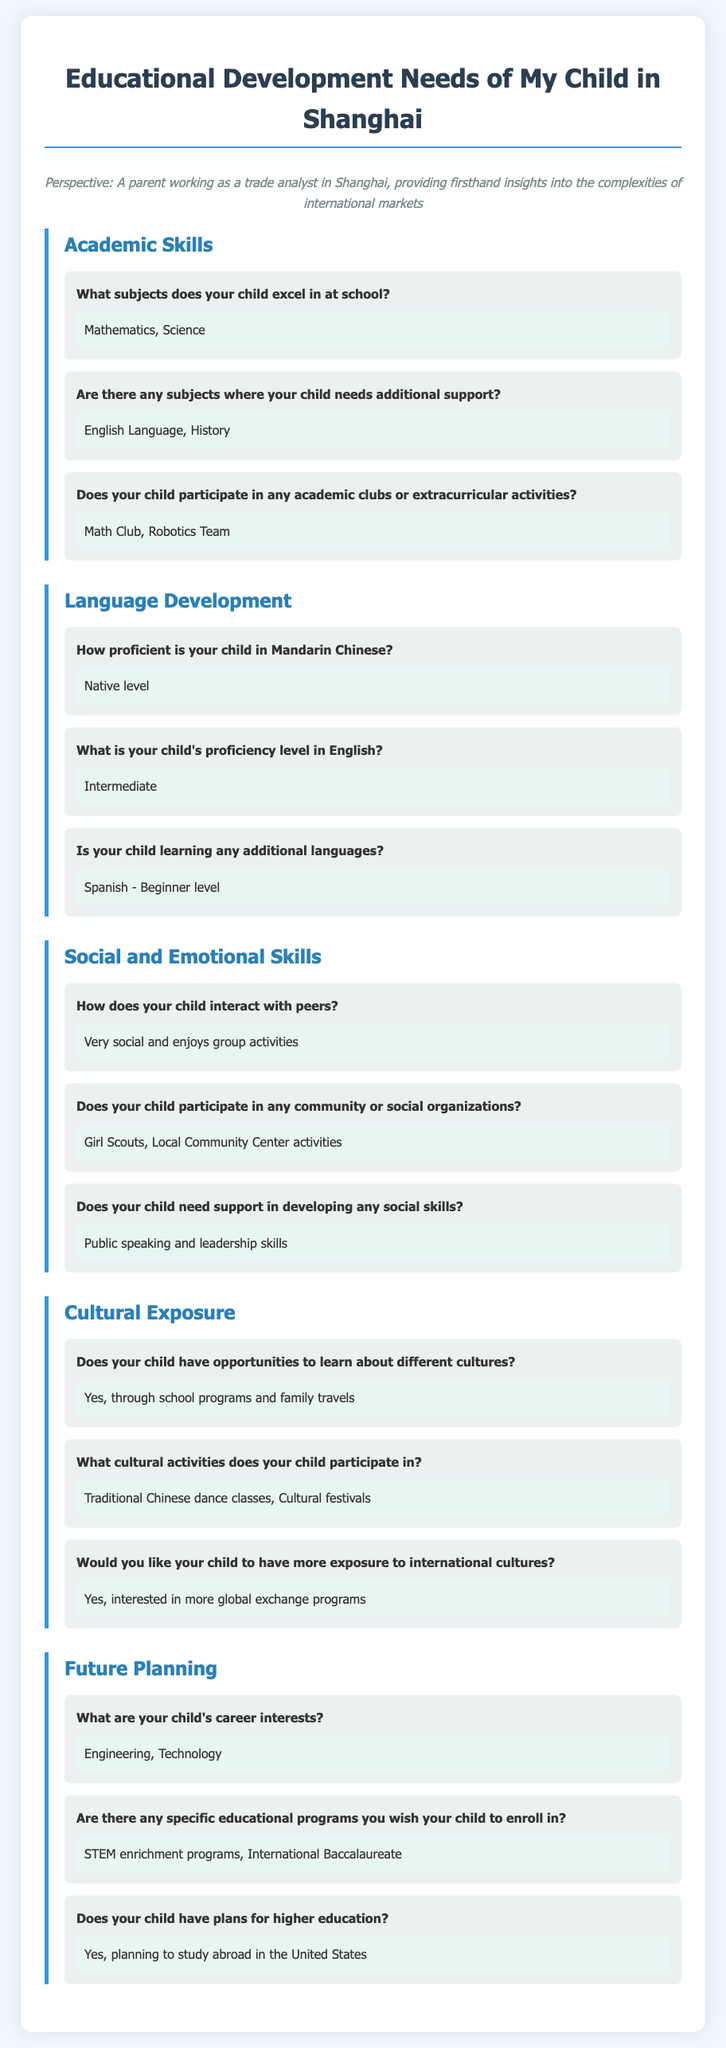What subjects does your child excel in at school? The document lists the subjects where the child excels in school, specifically mentioning Mathematics and Science.
Answer: Mathematics, Science Are there any subjects where your child needs additional support? The document provides information about subjects that require additional support for the child, which are English Language and History.
Answer: English Language, History What extracurricular activities does your child participate in? The document mentions specific academic clubs and teams that the child is part of, including the Math Club and Robotics Team.
Answer: Math Club, Robotics Team What is your child's proficiency level in English? The document states the proficiency level of English for the child as Intermediate.
Answer: Intermediate Does your child participate in any community or social organizations? The document indicates that the child is involved in the Girl Scouts and local community center activities.
Answer: Girl Scouts, Local Community Center activities What cultural activities does your child participate in? The document lists cultural activities in which the child engages, highlighting traditional Chinese dance classes and cultural festivals.
Answer: Traditional Chinese dance classes, Cultural festivals Are there any specific educational programs you wish your child to enroll in? The document specifies desired educational programs, stating STEM enrichment programs and International Baccalaureate.
Answer: STEM enrichment programs, International Baccalaureate What are your child's career interests? The document details the career interests of the child, specifically mentioning Engineering and Technology as areas of interest.
Answer: Engineering, Technology Does your child have plans for higher education? The document provides information regarding future educational plans, indicating a desire to study abroad in the United States.
Answer: Yes, planning to study abroad in the United States 